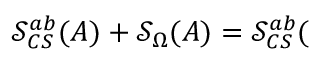Convert formula to latex. <formula><loc_0><loc_0><loc_500><loc_500>\mathcal { S } _ { C S } ^ { a b } ( A ) + \mathcal { S } _ { \Omega } ( A ) = \mathcal { S } _ { C S } ^ { a b } (</formula> 